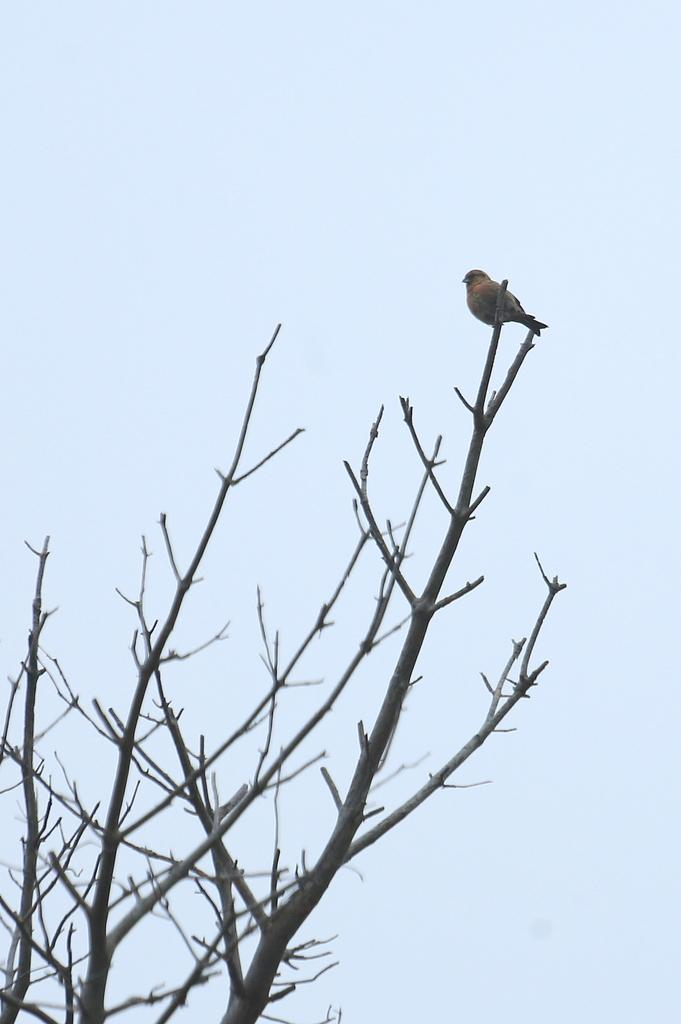What type of animal can be seen in the image? There is a bird in the image. Where is the bird located? The bird is standing on a tree. What can be seen in the background of the image? The sky is visible in the background of the image. What is the condition of the sky in the image? There are clouds in the sky. What type of mine is visible in the image? There is no mine present in the image; it features a bird standing on a tree with clouds in the sky. How many goats are present in the image? There are no goats present in the image; it features a bird standing on a tree with clouds in the sky. 